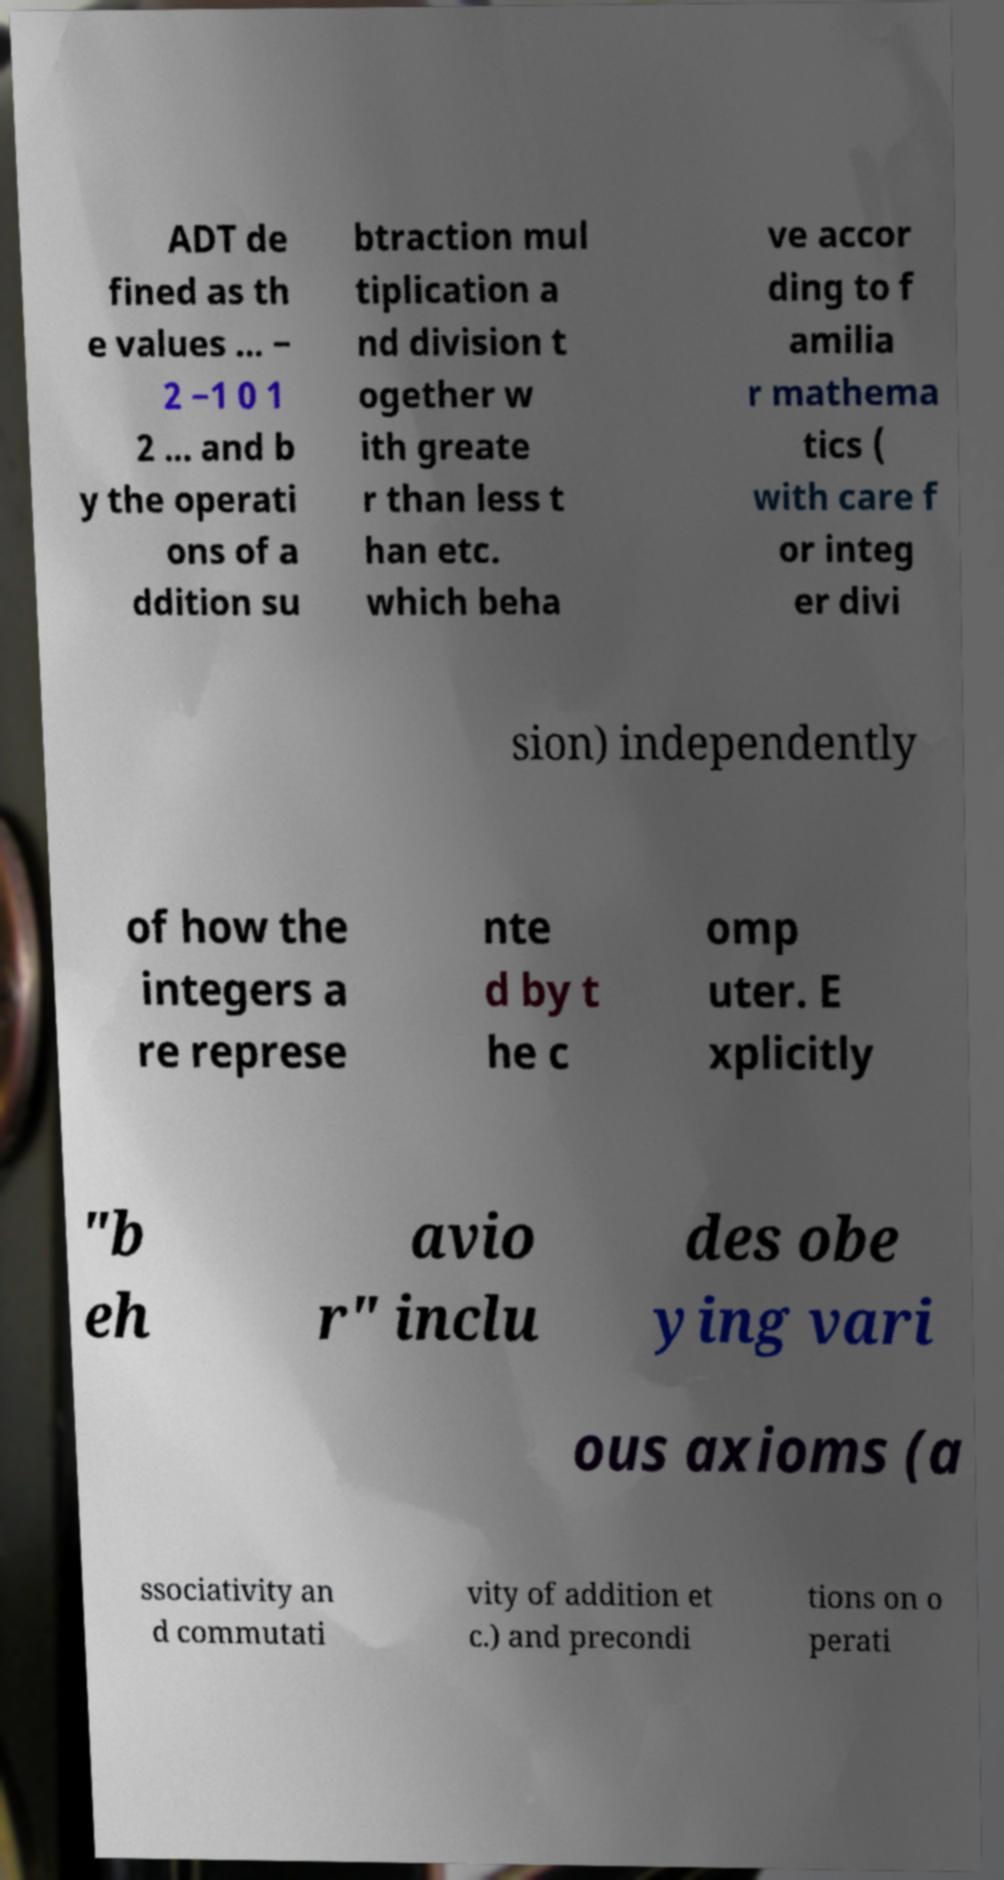For documentation purposes, I need the text within this image transcribed. Could you provide that? ADT de fined as th e values ... − 2 −1 0 1 2 ... and b y the operati ons of a ddition su btraction mul tiplication a nd division t ogether w ith greate r than less t han etc. which beha ve accor ding to f amilia r mathema tics ( with care f or integ er divi sion) independently of how the integers a re represe nte d by t he c omp uter. E xplicitly "b eh avio r" inclu des obe ying vari ous axioms (a ssociativity an d commutati vity of addition et c.) and precondi tions on o perati 